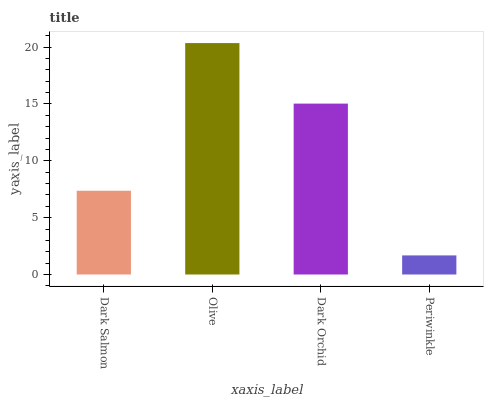Is Periwinkle the minimum?
Answer yes or no. Yes. Is Olive the maximum?
Answer yes or no. Yes. Is Dark Orchid the minimum?
Answer yes or no. No. Is Dark Orchid the maximum?
Answer yes or no. No. Is Olive greater than Dark Orchid?
Answer yes or no. Yes. Is Dark Orchid less than Olive?
Answer yes or no. Yes. Is Dark Orchid greater than Olive?
Answer yes or no. No. Is Olive less than Dark Orchid?
Answer yes or no. No. Is Dark Orchid the high median?
Answer yes or no. Yes. Is Dark Salmon the low median?
Answer yes or no. Yes. Is Olive the high median?
Answer yes or no. No. Is Dark Orchid the low median?
Answer yes or no. No. 